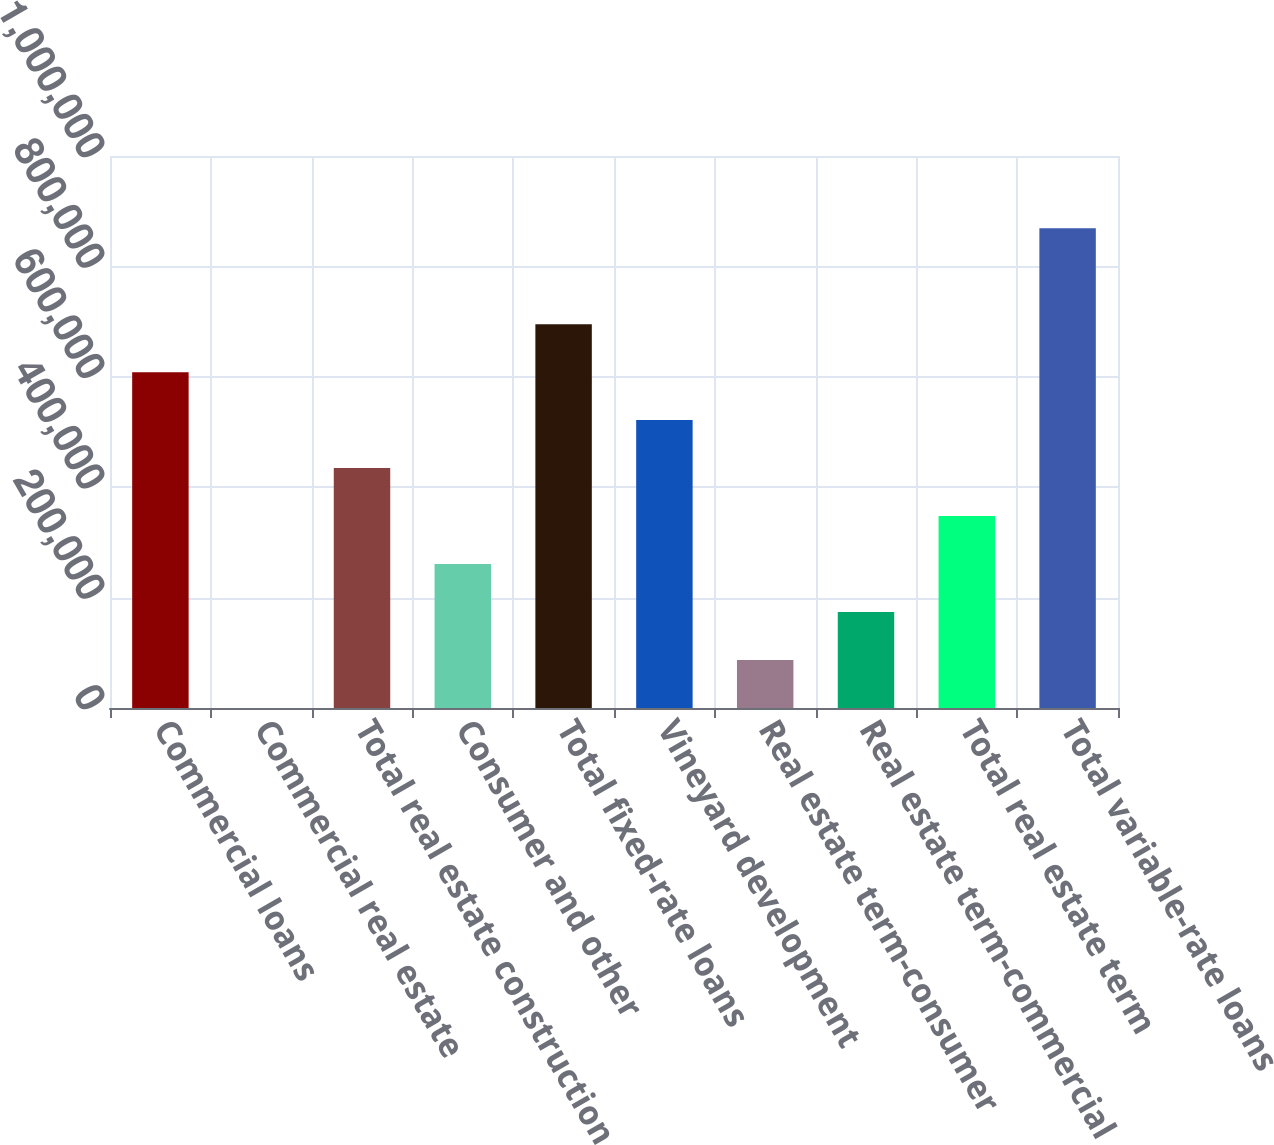Convert chart to OTSL. <chart><loc_0><loc_0><loc_500><loc_500><bar_chart><fcel>Commercial loans<fcel>Commercial real estate<fcel>Total real estate construction<fcel>Consumer and other<fcel>Total fixed-rate loans<fcel>Vineyard development<fcel>Real estate term-consumer<fcel>Real estate term-commercial<fcel>Total real estate term<fcel>Total variable-rate loans<nl><fcel>608442<fcel>50<fcel>434616<fcel>260789<fcel>695355<fcel>521529<fcel>86963.1<fcel>173876<fcel>347702<fcel>869181<nl></chart> 